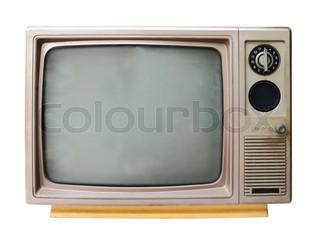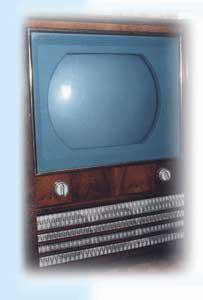The first image is the image on the left, the second image is the image on the right. For the images shown, is this caption "There is an antique television in the center of both of the images." true? Answer yes or no. Yes. The first image is the image on the left, the second image is the image on the right. Given the left and right images, does the statement "In one image, a TV has a screen with left and right sides that are curved outward and a flat top and bottom." hold true? Answer yes or no. Yes. 